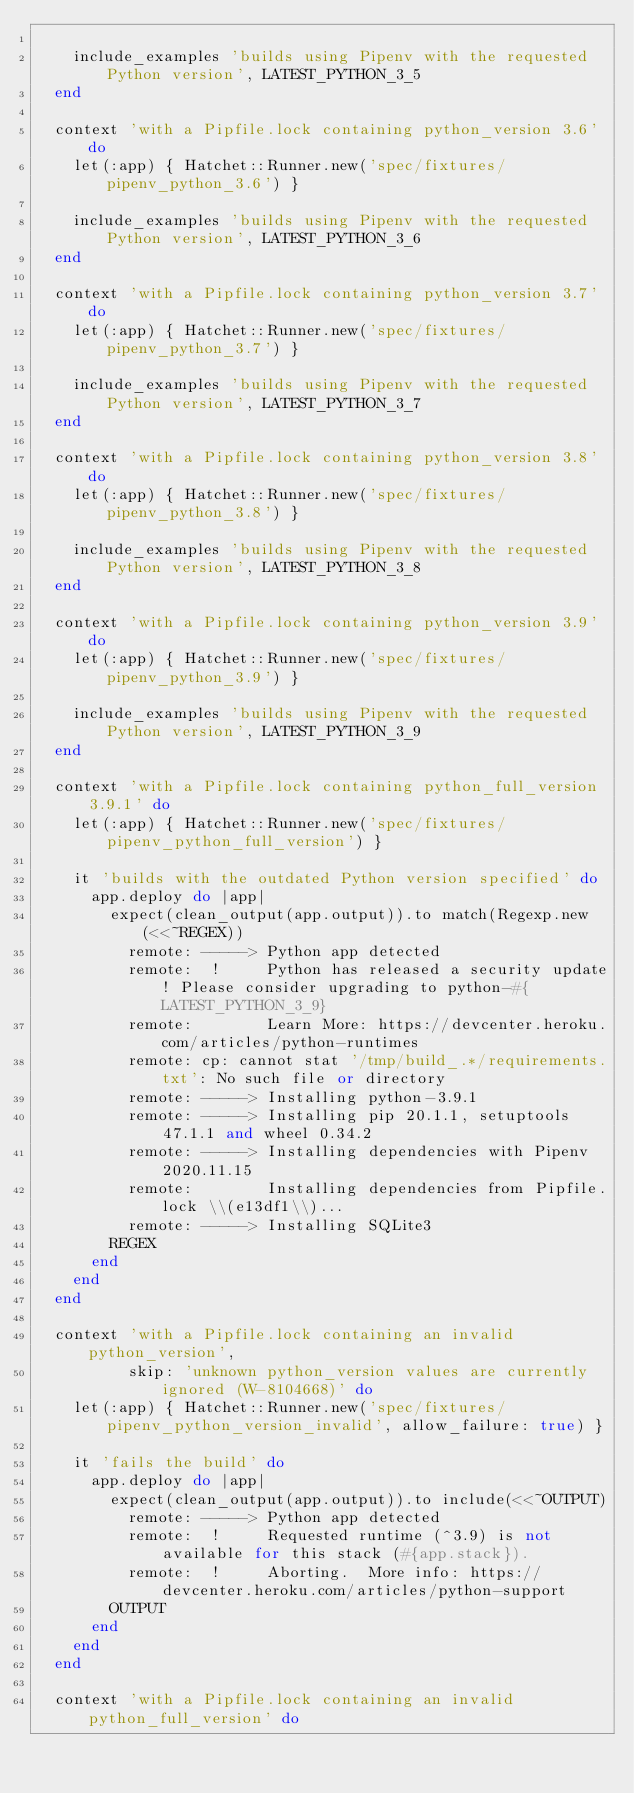<code> <loc_0><loc_0><loc_500><loc_500><_Ruby_>
    include_examples 'builds using Pipenv with the requested Python version', LATEST_PYTHON_3_5
  end

  context 'with a Pipfile.lock containing python_version 3.6' do
    let(:app) { Hatchet::Runner.new('spec/fixtures/pipenv_python_3.6') }

    include_examples 'builds using Pipenv with the requested Python version', LATEST_PYTHON_3_6
  end

  context 'with a Pipfile.lock containing python_version 3.7' do
    let(:app) { Hatchet::Runner.new('spec/fixtures/pipenv_python_3.7') }

    include_examples 'builds using Pipenv with the requested Python version', LATEST_PYTHON_3_7
  end

  context 'with a Pipfile.lock containing python_version 3.8' do
    let(:app) { Hatchet::Runner.new('spec/fixtures/pipenv_python_3.8') }

    include_examples 'builds using Pipenv with the requested Python version', LATEST_PYTHON_3_8
  end

  context 'with a Pipfile.lock containing python_version 3.9' do
    let(:app) { Hatchet::Runner.new('spec/fixtures/pipenv_python_3.9') }

    include_examples 'builds using Pipenv with the requested Python version', LATEST_PYTHON_3_9
  end

  context 'with a Pipfile.lock containing python_full_version 3.9.1' do
    let(:app) { Hatchet::Runner.new('spec/fixtures/pipenv_python_full_version') }

    it 'builds with the outdated Python version specified' do
      app.deploy do |app|
        expect(clean_output(app.output)).to match(Regexp.new(<<~REGEX))
          remote: -----> Python app detected
          remote:  !     Python has released a security update! Please consider upgrading to python-#{LATEST_PYTHON_3_9}
          remote:        Learn More: https://devcenter.heroku.com/articles/python-runtimes
          remote: cp: cannot stat '/tmp/build_.*/requirements.txt': No such file or directory
          remote: -----> Installing python-3.9.1
          remote: -----> Installing pip 20.1.1, setuptools 47.1.1 and wheel 0.34.2
          remote: -----> Installing dependencies with Pipenv 2020.11.15
          remote:        Installing dependencies from Pipfile.lock \\(e13df1\\)...
          remote: -----> Installing SQLite3
        REGEX
      end
    end
  end

  context 'with a Pipfile.lock containing an invalid python_version',
          skip: 'unknown python_version values are currently ignored (W-8104668)' do
    let(:app) { Hatchet::Runner.new('spec/fixtures/pipenv_python_version_invalid', allow_failure: true) }

    it 'fails the build' do
      app.deploy do |app|
        expect(clean_output(app.output)).to include(<<~OUTPUT)
          remote: -----> Python app detected
          remote:  !     Requested runtime (^3.9) is not available for this stack (#{app.stack}).
          remote:  !     Aborting.  More info: https://devcenter.heroku.com/articles/python-support
        OUTPUT
      end
    end
  end

  context 'with a Pipfile.lock containing an invalid python_full_version' do</code> 